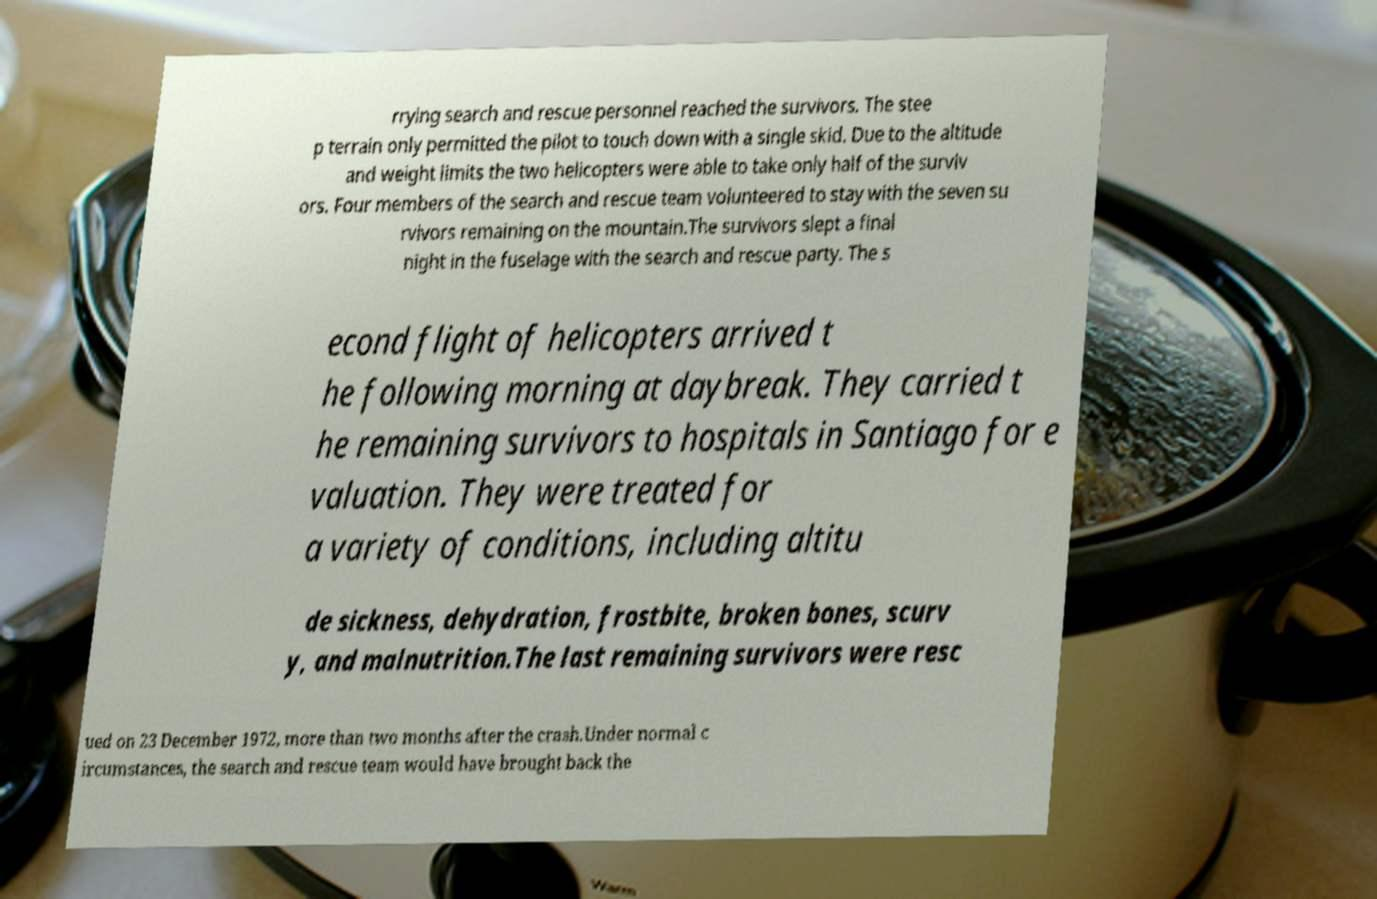There's text embedded in this image that I need extracted. Can you transcribe it verbatim? rrying search and rescue personnel reached the survivors. The stee p terrain only permitted the pilot to touch down with a single skid. Due to the altitude and weight limits the two helicopters were able to take only half of the surviv ors. Four members of the search and rescue team volunteered to stay with the seven su rvivors remaining on the mountain.The survivors slept a final night in the fuselage with the search and rescue party. The s econd flight of helicopters arrived t he following morning at daybreak. They carried t he remaining survivors to hospitals in Santiago for e valuation. They were treated for a variety of conditions, including altitu de sickness, dehydration, frostbite, broken bones, scurv y, and malnutrition.The last remaining survivors were resc ued on 23 December 1972, more than two months after the crash.Under normal c ircumstances, the search and rescue team would have brought back the 